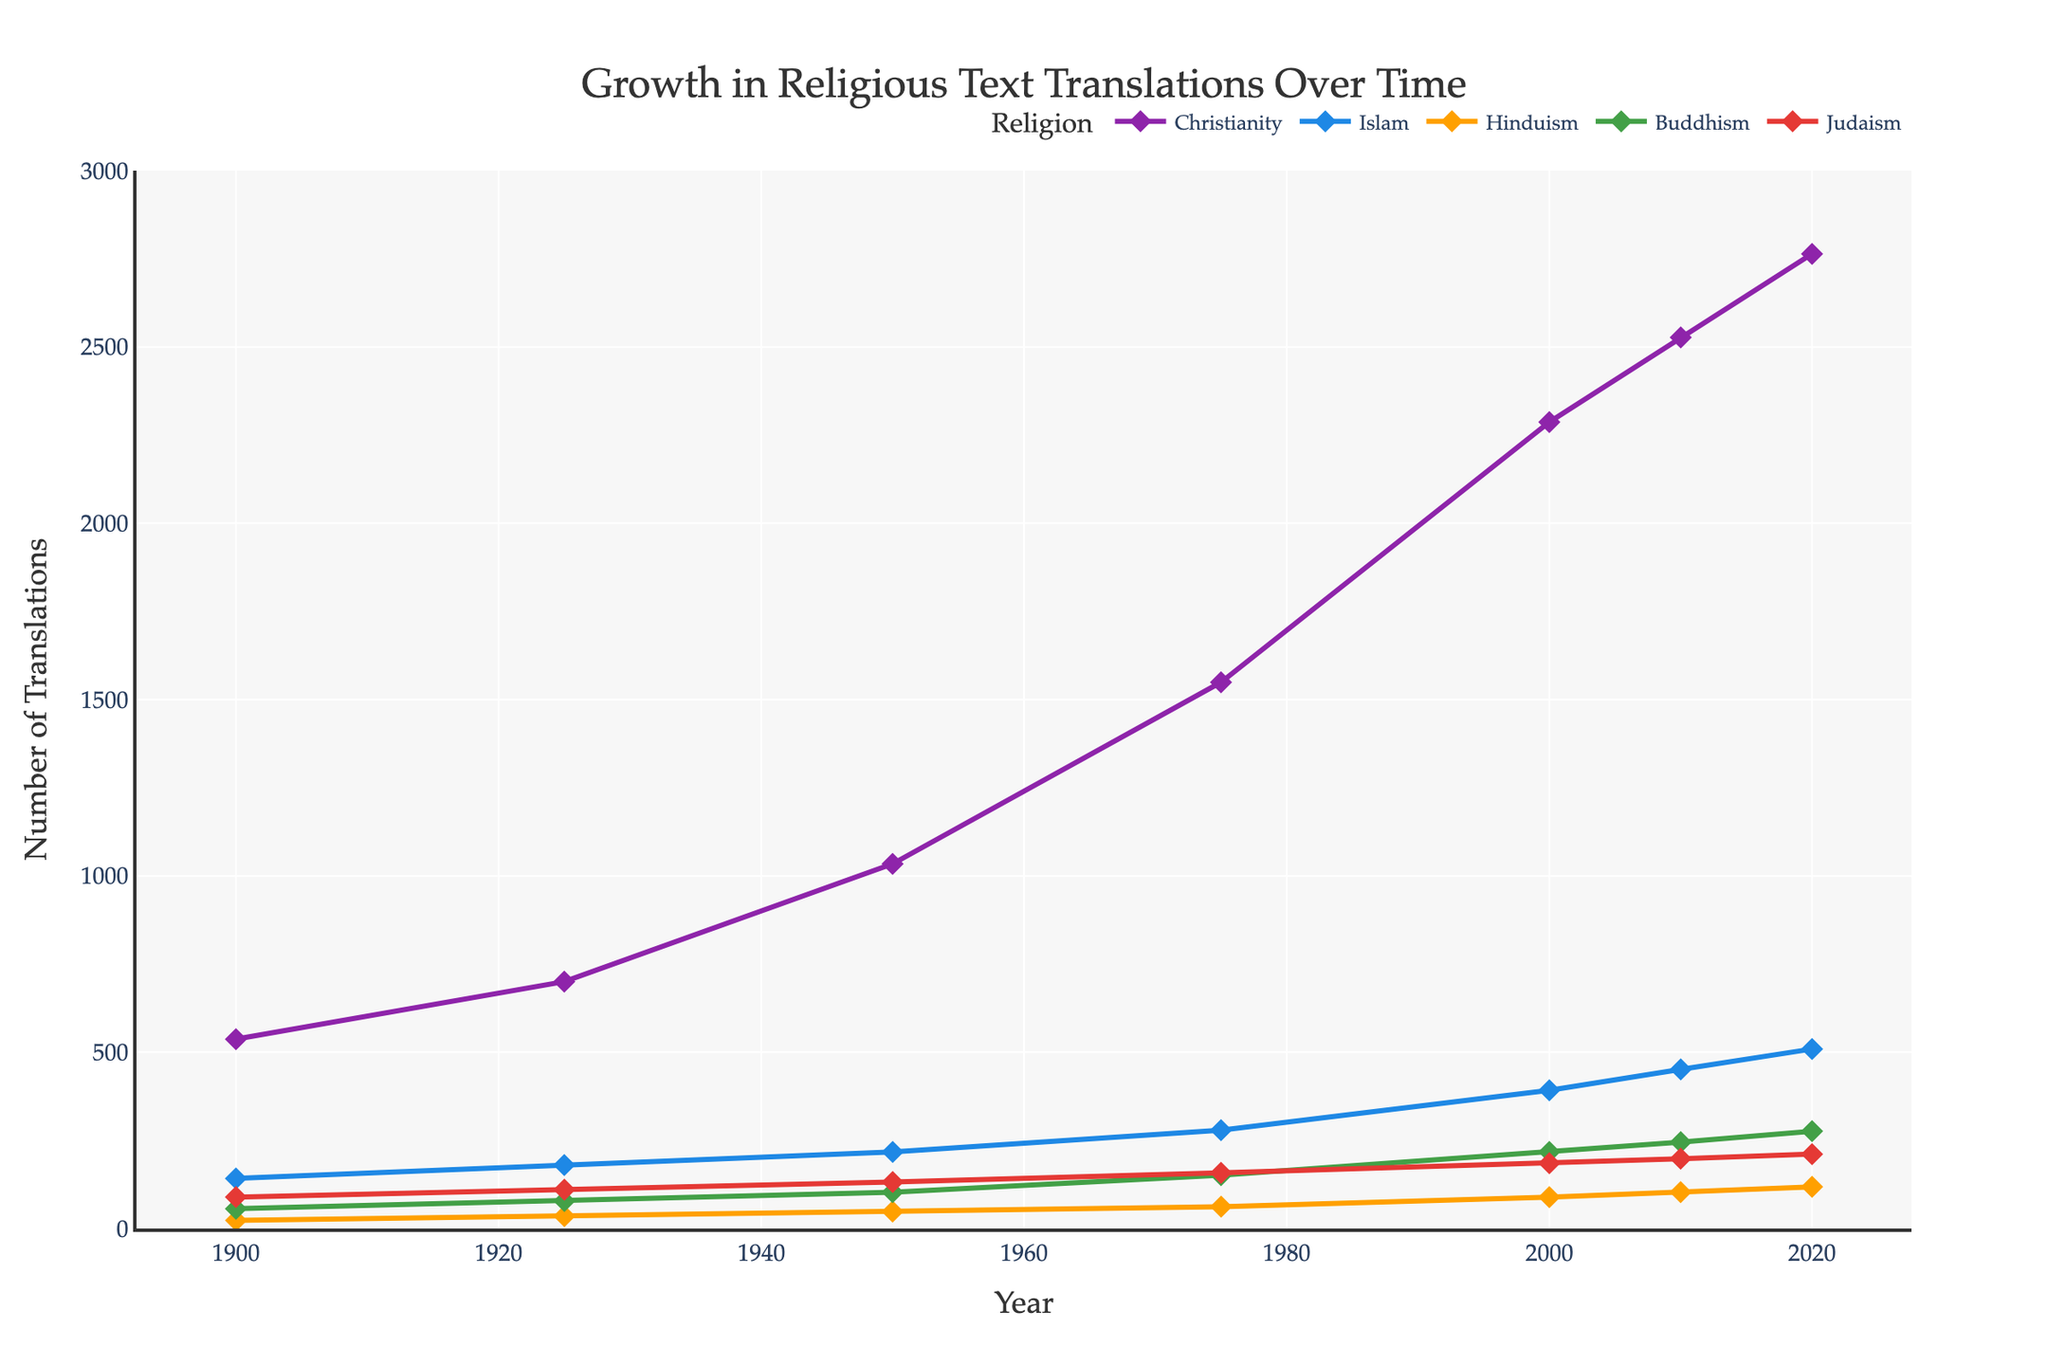what's the total number of translations across all religions in 2020? Sum the values for each religion in the year 2020: 2764 (Christianity) + 509 (Islam) + 118 (Hinduism) + 276 (Buddhism) + 211 (Judaism) = 3878
Answer: 3878 which religion had the largest increase in the number of translations between 1900 and 2020? Calculate the difference for each religion between 1900 and 2020, then find the maximum: Christianity (2764-537=2227), Islam (509-142=367), Hinduism (118-23=95), Buddhism (276-56=220), Judaism (211-89=122). The largest increase is for Christianity (2227)
Answer: Christianity which year shows the closest number of translations for Hinduism and Buddhism? Look at the differences between the numbers for Hinduism and Buddhism in each year and find the smallest difference: 1900 (33), 1925 (43), 1950 (55), 1975 (89), 2000 (128), 2010 (142), 2020 (158). The smallest difference is for the year 1900 (33)
Answer: 1900 in what period did Christianity see the sharpest increase in translations? Evaluate the differences between subsequent years for Christianity and identify the period with the largest increase: 1900-1925 (+163), 1925-1950 (+334), 1950-1975 (+515), 1975-2000 (+738), 2000-2010 (+240), 2010-2020 (+237). The sharpest increase is between 1975 and 2000 (+738)
Answer: 1975-2000 in 2020, how does the number of translations of Buddhism compare to that of Judaism? Compare the values for Buddhism and Judaism in 2020: Buddhism (276) and Judaism (211). Buddhism has more translations: 276 - 211 = 65
Answer: Buddhism has 65 more what is the average number of translations for Islam over all the years shown? Sum the number of translations for Islam over all years and divide by the number of years: (142 + 180 + 217 + 279 + 392 + 451 + 509) / 7 = 310
Answer: 310 which religion showed a steady increase in the number of translations over the years without any decrease? Check the data for each religion to see if there's no decrease: Christianity, Islam, Hinduism, Buddhism, Judaism all increased steadily
Answer: All religions how many times did Buddhism's number of translations cross 200? Check in which years Buddhism's translations were more than 200: 2000 (217), 2010 (245), 2020 (276). It crossed 200 three times
Answer: 3 which religion had the least number of translations in 2000, and what was the number? Compare numbers for 2000 and identify the smallest: Christianity (2287), Islam (392), Hinduism (89), Buddhism (217), Judaism (185). The least number of translations was for Hinduism (89)
Answer: Hinduism, 89 how does the total number of translations in 1925 compare to that in 1975 across all religions? Calculate the total for all religions in 1925 and 1975 separately and compare the sums: 1925 (1103) and 1975 (2199). The difference is 2199 - 1103 = 1096
Answer: 1975 has 1096 more 